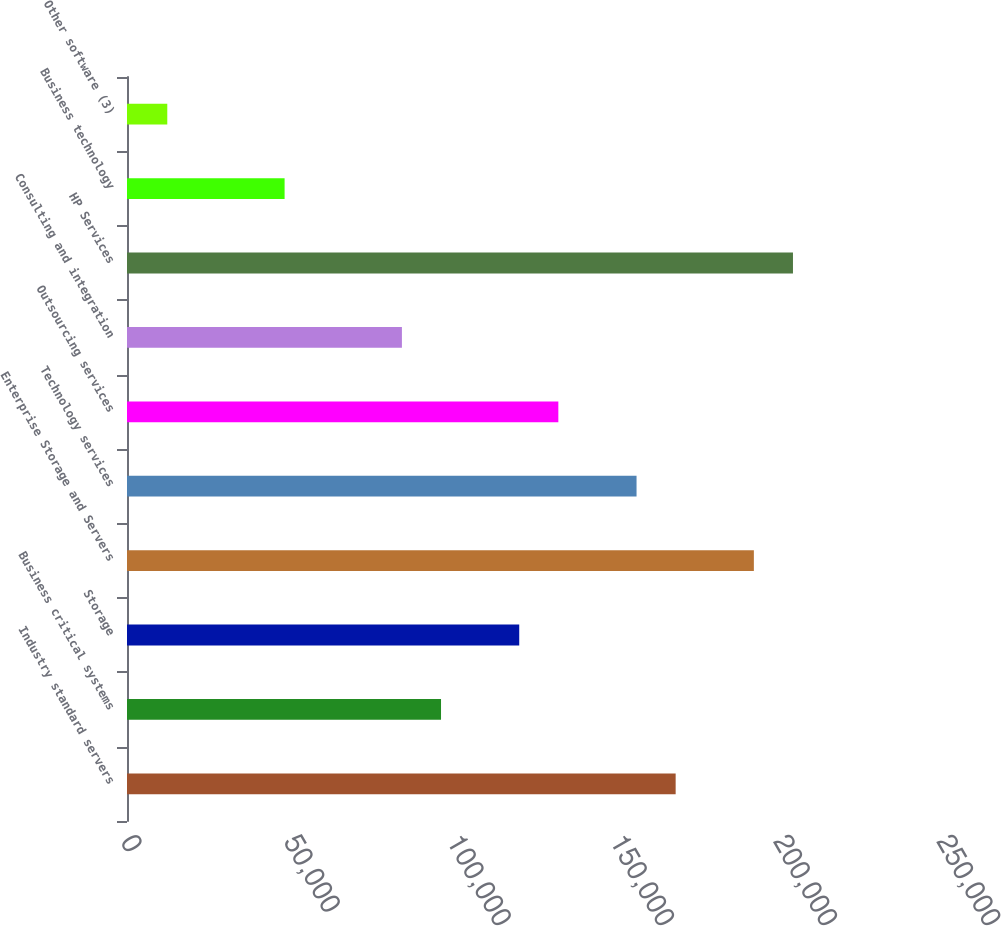<chart> <loc_0><loc_0><loc_500><loc_500><bar_chart><fcel>Industry standard servers<fcel>Business critical systems<fcel>Storage<fcel>Enterprise Storage and Servers<fcel>Technology services<fcel>Outsourcing services<fcel>Consulting and integration<fcel>HP Services<fcel>Business technology<fcel>Other software (3)<nl><fcel>168093<fcel>96207.2<fcel>120169<fcel>192054<fcel>156112<fcel>132150<fcel>84226.3<fcel>204035<fcel>48283.6<fcel>12340.9<nl></chart> 